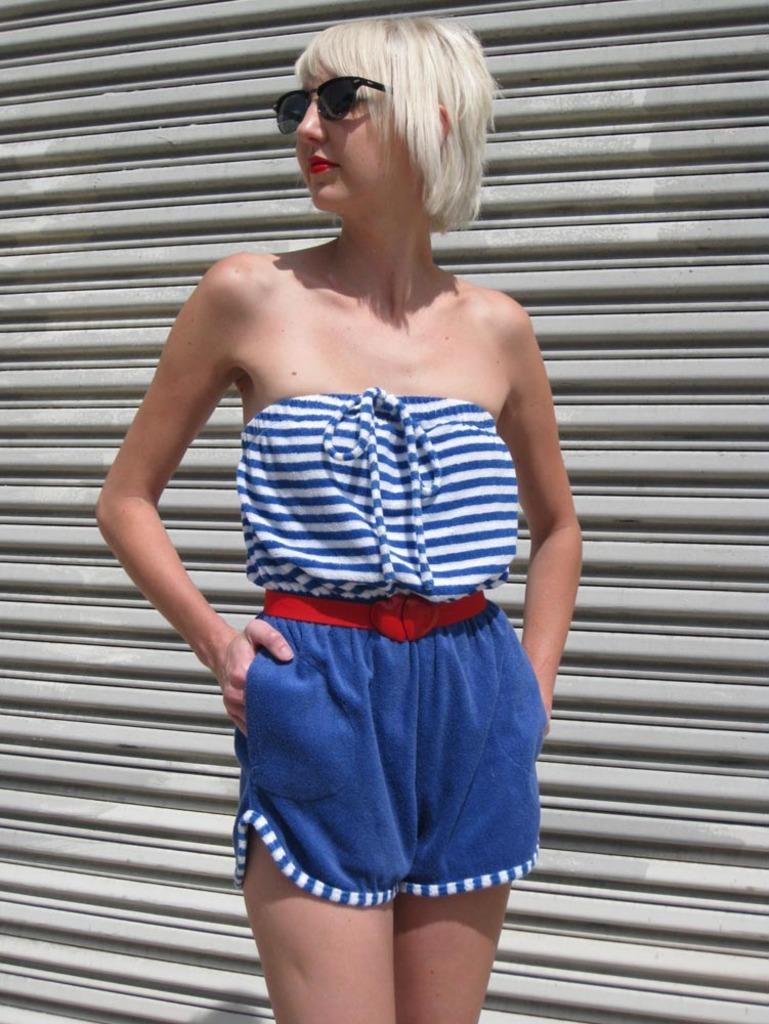What is the main subject of the image? There is a person in the image. Can you describe the person's appearance? The person is wearing spectacles. What is the person's posture in the image? The person is standing. What can be seen in the background of the image? There is a shutter in the background of the image. What type of harmony is being played in the background of the image? There is no harmony being played in the background of the image; it only features a person standing with spectacles and a shutter in the background. Can you describe the patch on the person's clothing in the image? There is no patch mentioned or visible on the person's clothing in the image. 